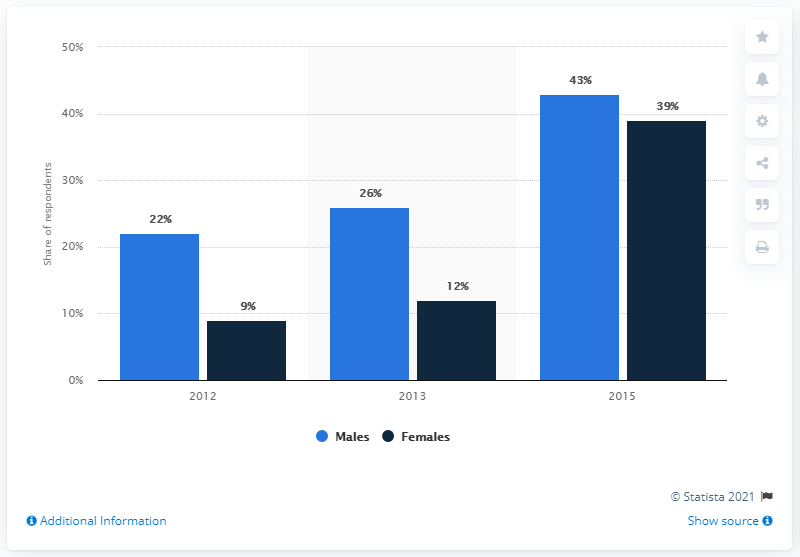Give some essential details in this illustration. In 2015, there was a dark blue bar value located near a blue bar value. The average of all blue bars is 30.33. 